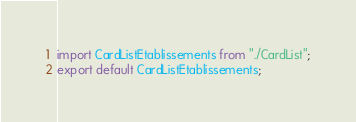<code> <loc_0><loc_0><loc_500><loc_500><_JavaScript_>import CardListEtablissements from "./CardList";
export default CardListEtablissements;
</code> 